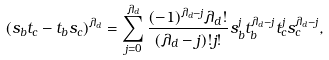Convert formula to latex. <formula><loc_0><loc_0><loc_500><loc_500>( s _ { b } t _ { c } - t _ { b } s _ { c } ) ^ { \lambda _ { d } } = \sum _ { j = 0 } ^ { \lambda _ { d } } \frac { ( - 1 ) ^ { \lambda _ { d } - j } \lambda _ { d } ! } { ( \lambda _ { d } - j ) ! j ! } s _ { b } ^ { j } t _ { b } ^ { \lambda _ { d } - j } t _ { c } ^ { j } s _ { c } ^ { \lambda _ { d } - j } ,</formula> 